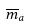<formula> <loc_0><loc_0><loc_500><loc_500>\overline { m } _ { a }</formula> 